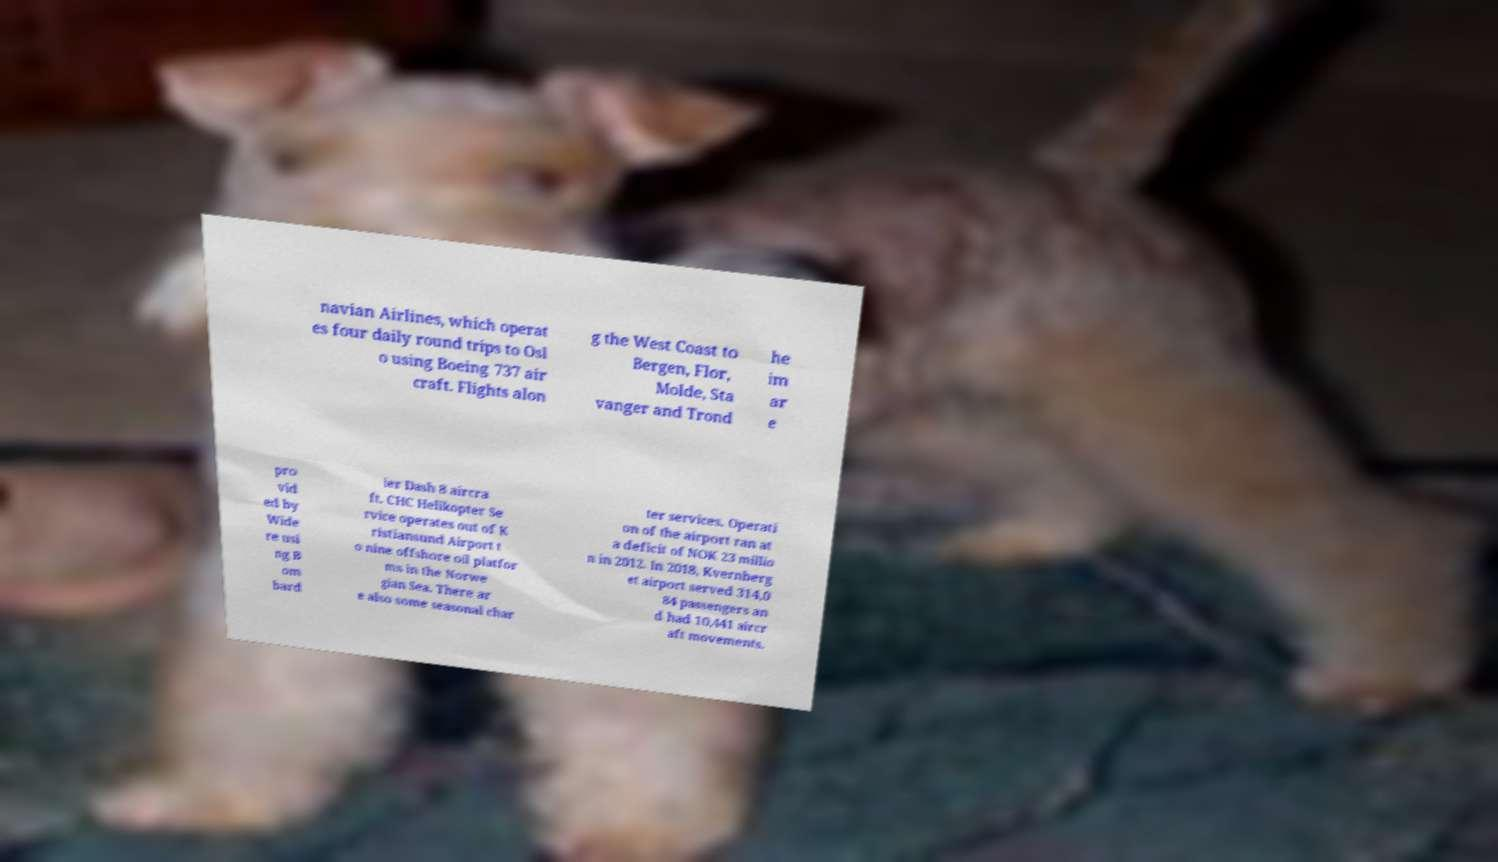Can you accurately transcribe the text from the provided image for me? navian Airlines, which operat es four daily round trips to Osl o using Boeing 737 air craft. Flights alon g the West Coast to Bergen, Flor, Molde, Sta vanger and Trond he im ar e pro vid ed by Wide re usi ng B om bard ier Dash 8 aircra ft. CHC Helikopter Se rvice operates out of K ristiansund Airport t o nine offshore oil platfor ms in the Norwe gian Sea. There ar e also some seasonal char ter services. Operati on of the airport ran at a deficit of NOK 23 millio n in 2012. In 2018, Kvernberg et airport served 314,0 84 passengers an d had 10,441 aircr aft movements. 